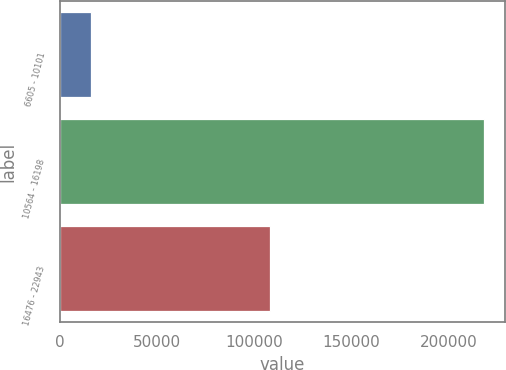Convert chart. <chart><loc_0><loc_0><loc_500><loc_500><bar_chart><fcel>6605 - 10101<fcel>10564 - 16198<fcel>16476 - 22943<nl><fcel>15901<fcel>218041<fcel>108106<nl></chart> 